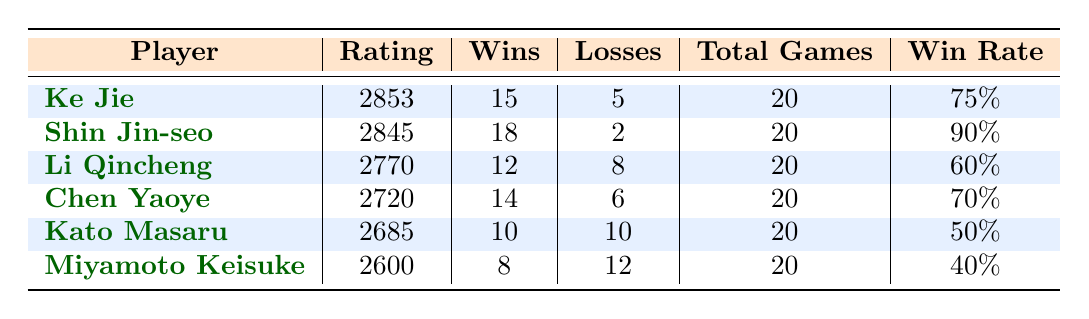What is the win rate of Shin Jin-seo? The win rate is calculated by dividing the number of wins by the total games played. Shin Jin-seo has 18 wins out of 20 games. Therefore, his win rate is 18/20 = 0.90 or 90%.
Answer: 90% How many total games has Kato Masaru played? Kato Masaru's total games are listed in the table under the "Total Games" column. The value for Kato Masaru is 20.
Answer: 20 Who has the highest rating among the players? By comparing the values in the "Rating" column, Ke Jie has the highest rating at 2853, followed closely by Shin Jin-seo with 2845.
Answer: Ke Jie Is Li Qincheng's win rate higher than Miyamoto Keisuke's? To determine this, calculate both players' win rates. Li Qincheng has a win rate of 12/20 = 0.60 or 60% and Miyamoto Keisuke has a win rate of 8/20 = 0.40 or 40%. Since 60% > 40%, Li Qincheng's win rate is higher.
Answer: Yes What is the difference in the number of wins between Ke Jie and Chen Yaoye? The number of wins for Ke Jie is 15, while for Chen Yaoye it is 14. The difference is 15 - 14 = 1.
Answer: 1 How many players have a win rate of 70% or higher? Looking at the win rates, Ke Jie (75%) and Shin Jin-seo (90%) have win rates higher than 70%. Therefore, there are 2 players.
Answer: 2 Does Kato Masaru have a winning record? A winning record means more wins than losses. Kato Masaru has 10 wins and 10 losses, which results in an equal win-loss record and does not count as a winning record.
Answer: No Calculate the average win rate of the players listed. To find the average win rate, sum the win rates of each player: 75% + 90% + 60% + 70% + 50% + 40% = 385%. Then divide by the number of players (6): 385% / 6 = 64.17%.
Answer: 64.17% 